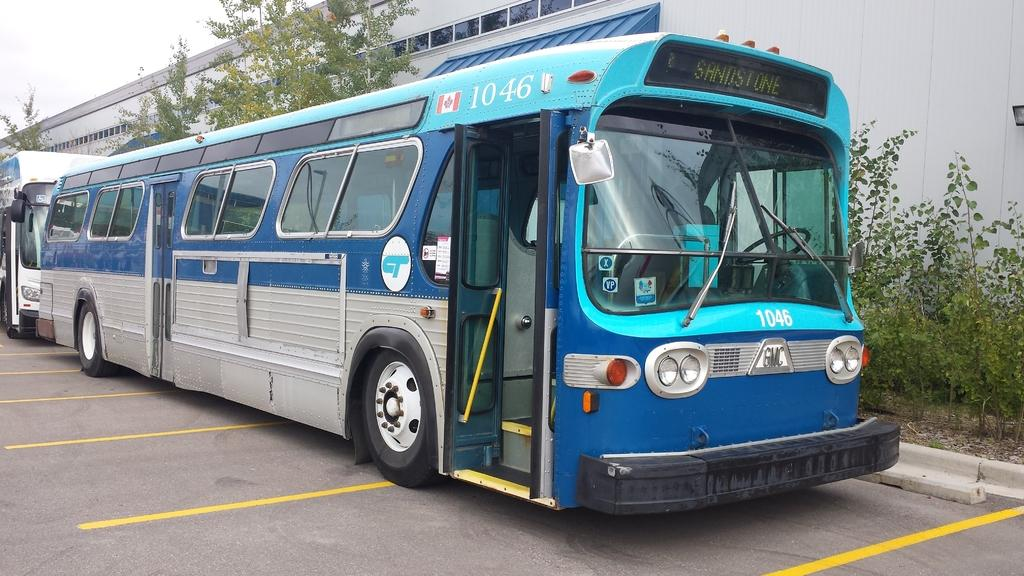What type of vehicles can be seen in the image? There are buses in the image. What natural elements are present in the image? There are trees and plants in the image. What type of structure is visible in the image? There is a building in the image. What part of the natural environment is visible in the image? The sky is visible in the image. How much salt is present in the image? There is no salt present in the image. Can you describe the girl in the image? There is no girl present in the image. 